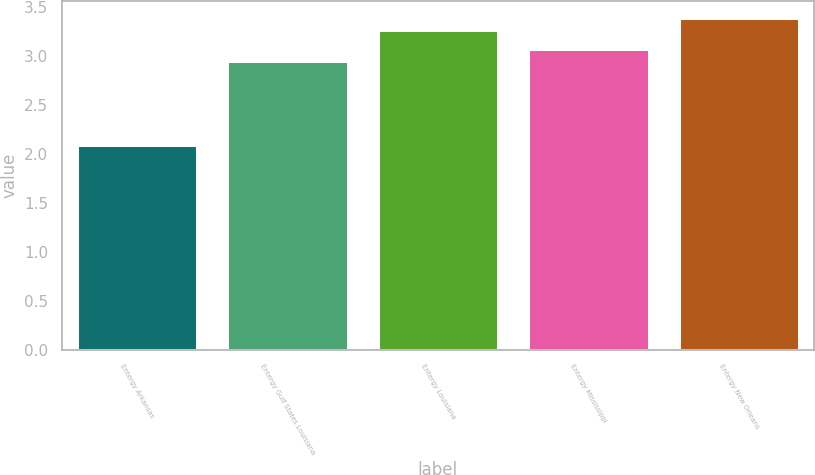Convert chart to OTSL. <chart><loc_0><loc_0><loc_500><loc_500><bar_chart><fcel>Entergy Arkansas<fcel>Entergy Gulf States Louisiana<fcel>Entergy Louisiana<fcel>Entergy Mississippi<fcel>Entergy New Orleans<nl><fcel>2.09<fcel>2.95<fcel>3.27<fcel>3.07<fcel>3.39<nl></chart> 